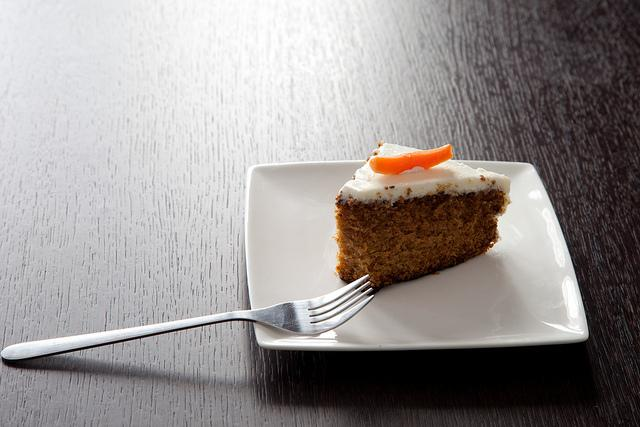What kind of cake has been served? Please explain your reasoning. carrot. The carrot and icing of the cake gives it away for what type of cake it is. 